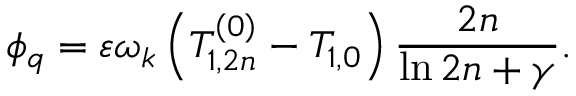<formula> <loc_0><loc_0><loc_500><loc_500>\phi _ { q } = \varepsilon \omega _ { k } \left ( T _ { 1 , 2 n } ^ { \left ( 0 \right ) } - T _ { 1 , 0 } \right ) \frac { 2 n } { \ln 2 n + \gamma } .</formula> 